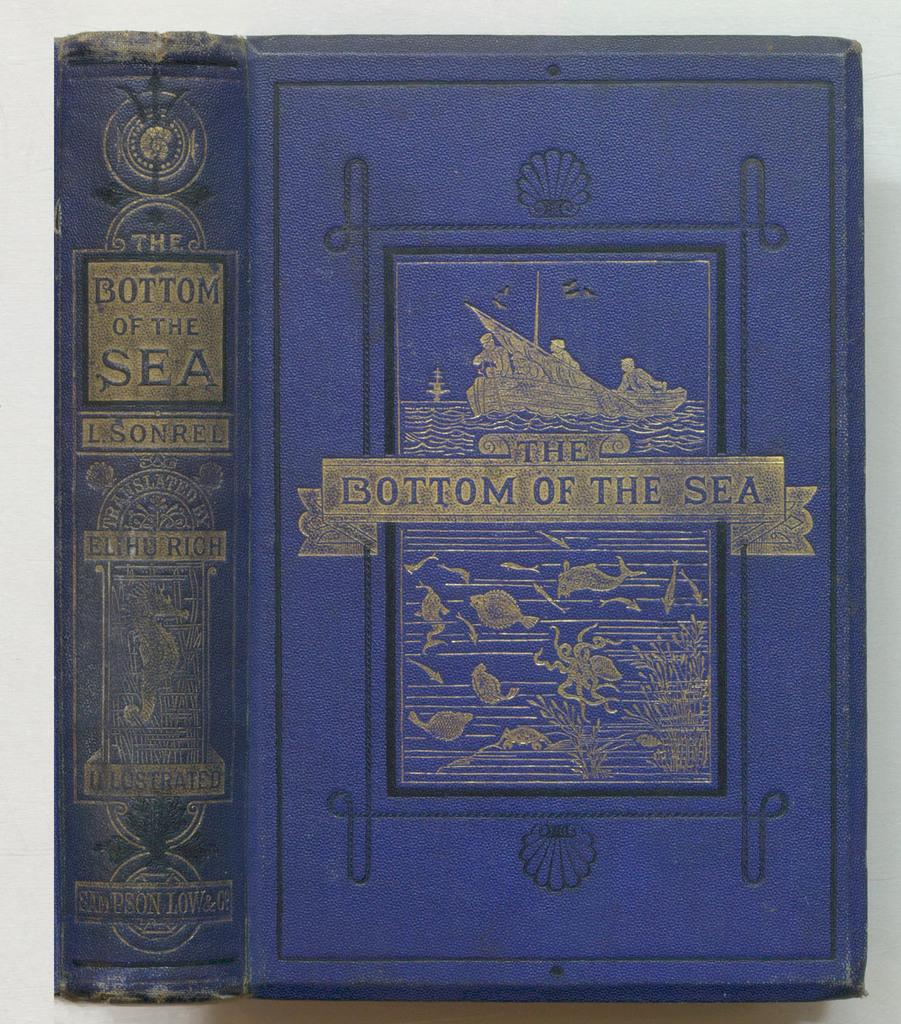<image>
Share a concise interpretation of the image provided. a blue book with the bottom of the sea written on it 